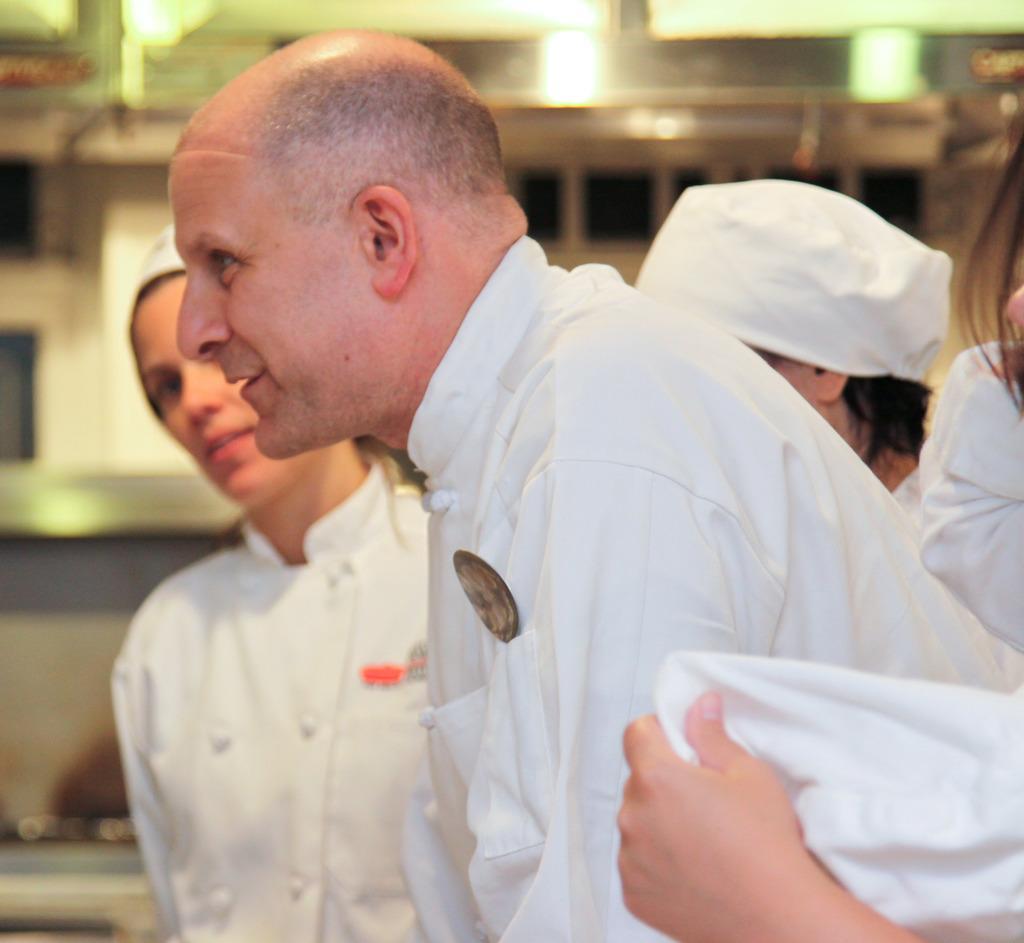How would you summarize this image in a sentence or two? In this image I can see few people and I can see all of them are wearing white dress. I can also see few of them are wearing white caps and I can see this image is little bit blurry from background. 